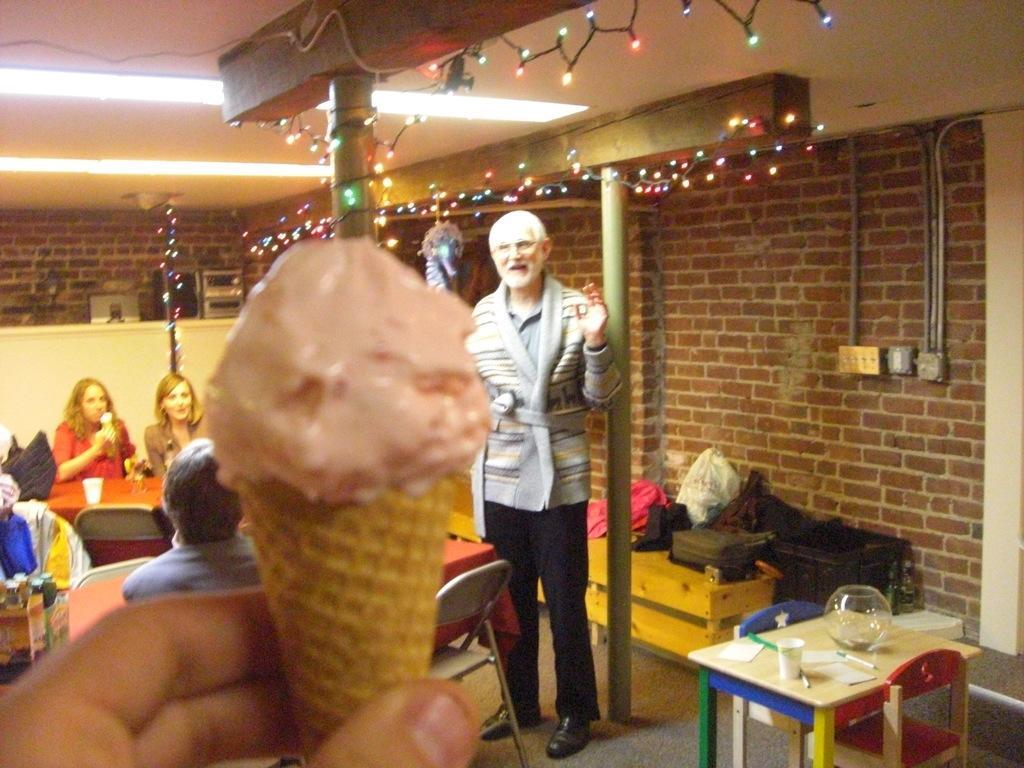Please provide a concise description of this image. The person is holding cone ice-creme in his hand and a person wearing black pant is standing in front of him and a person wearing red shirt is eating cone ice-cream and in top there are lighting's and the background is brick wall. 